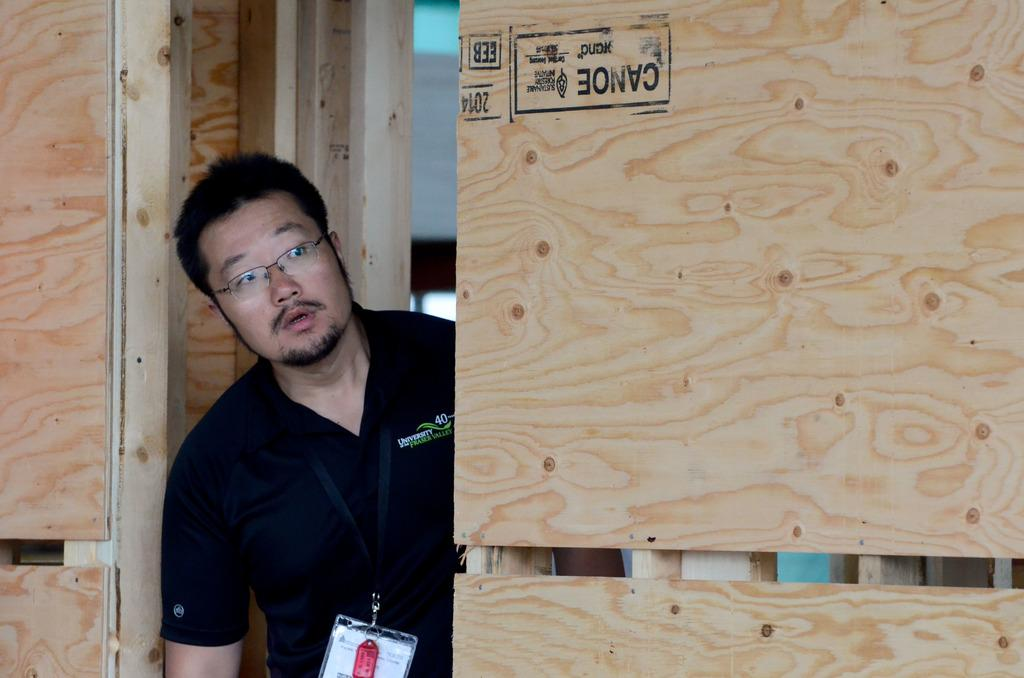What can be seen in the image? There is a person in the image. What is the person wearing? The person is wearing a black T-shirt. What type of material is visible on the right side of the side of the image? There is a wooden wall on the right side of the image. How many toes can be seen in the image? There is no visible indication of toes in the image, as the person's feet are not shown. 